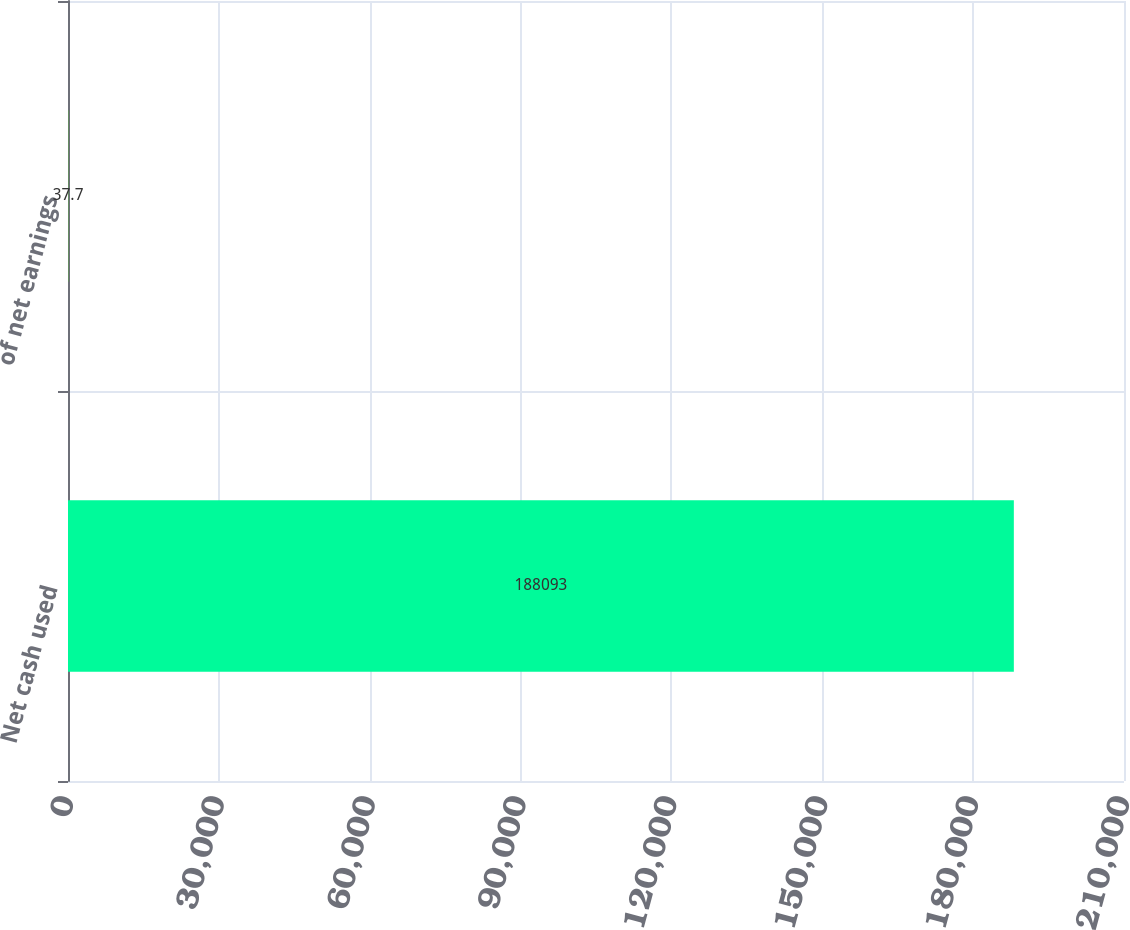<chart> <loc_0><loc_0><loc_500><loc_500><bar_chart><fcel>Net cash used<fcel>of net earnings<nl><fcel>188093<fcel>37.7<nl></chart> 